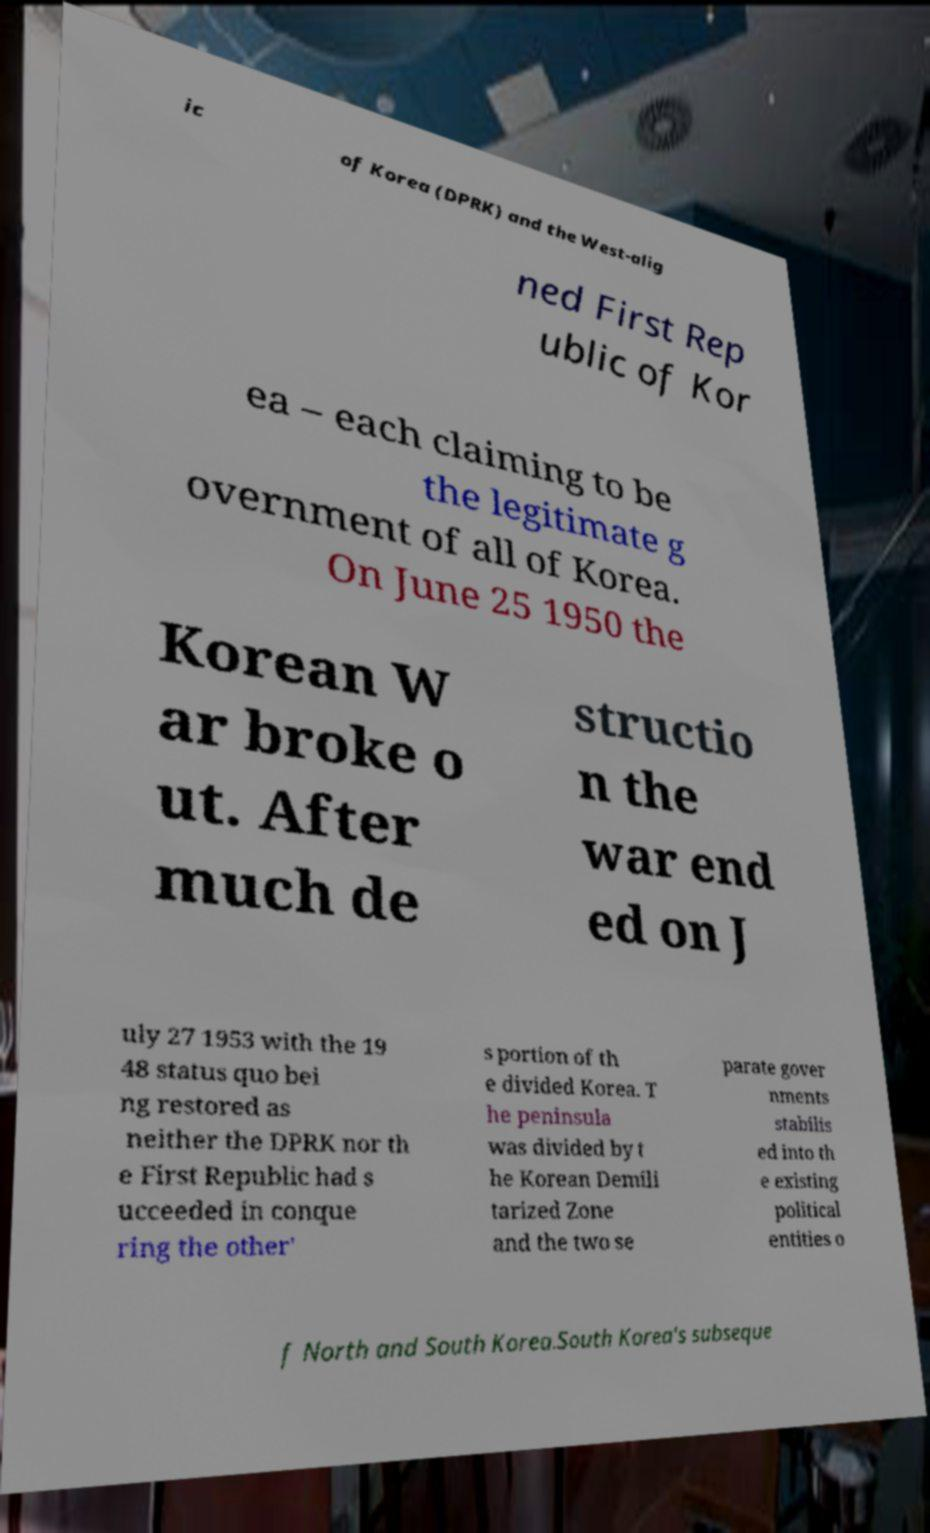Could you extract and type out the text from this image? ic of Korea (DPRK) and the West-alig ned First Rep ublic of Kor ea – each claiming to be the legitimate g overnment of all of Korea. On June 25 1950 the Korean W ar broke o ut. After much de structio n the war end ed on J uly 27 1953 with the 19 48 status quo bei ng restored as neither the DPRK nor th e First Republic had s ucceeded in conque ring the other' s portion of th e divided Korea. T he peninsula was divided by t he Korean Demili tarized Zone and the two se parate gover nments stabilis ed into th e existing political entities o f North and South Korea.South Korea's subseque 